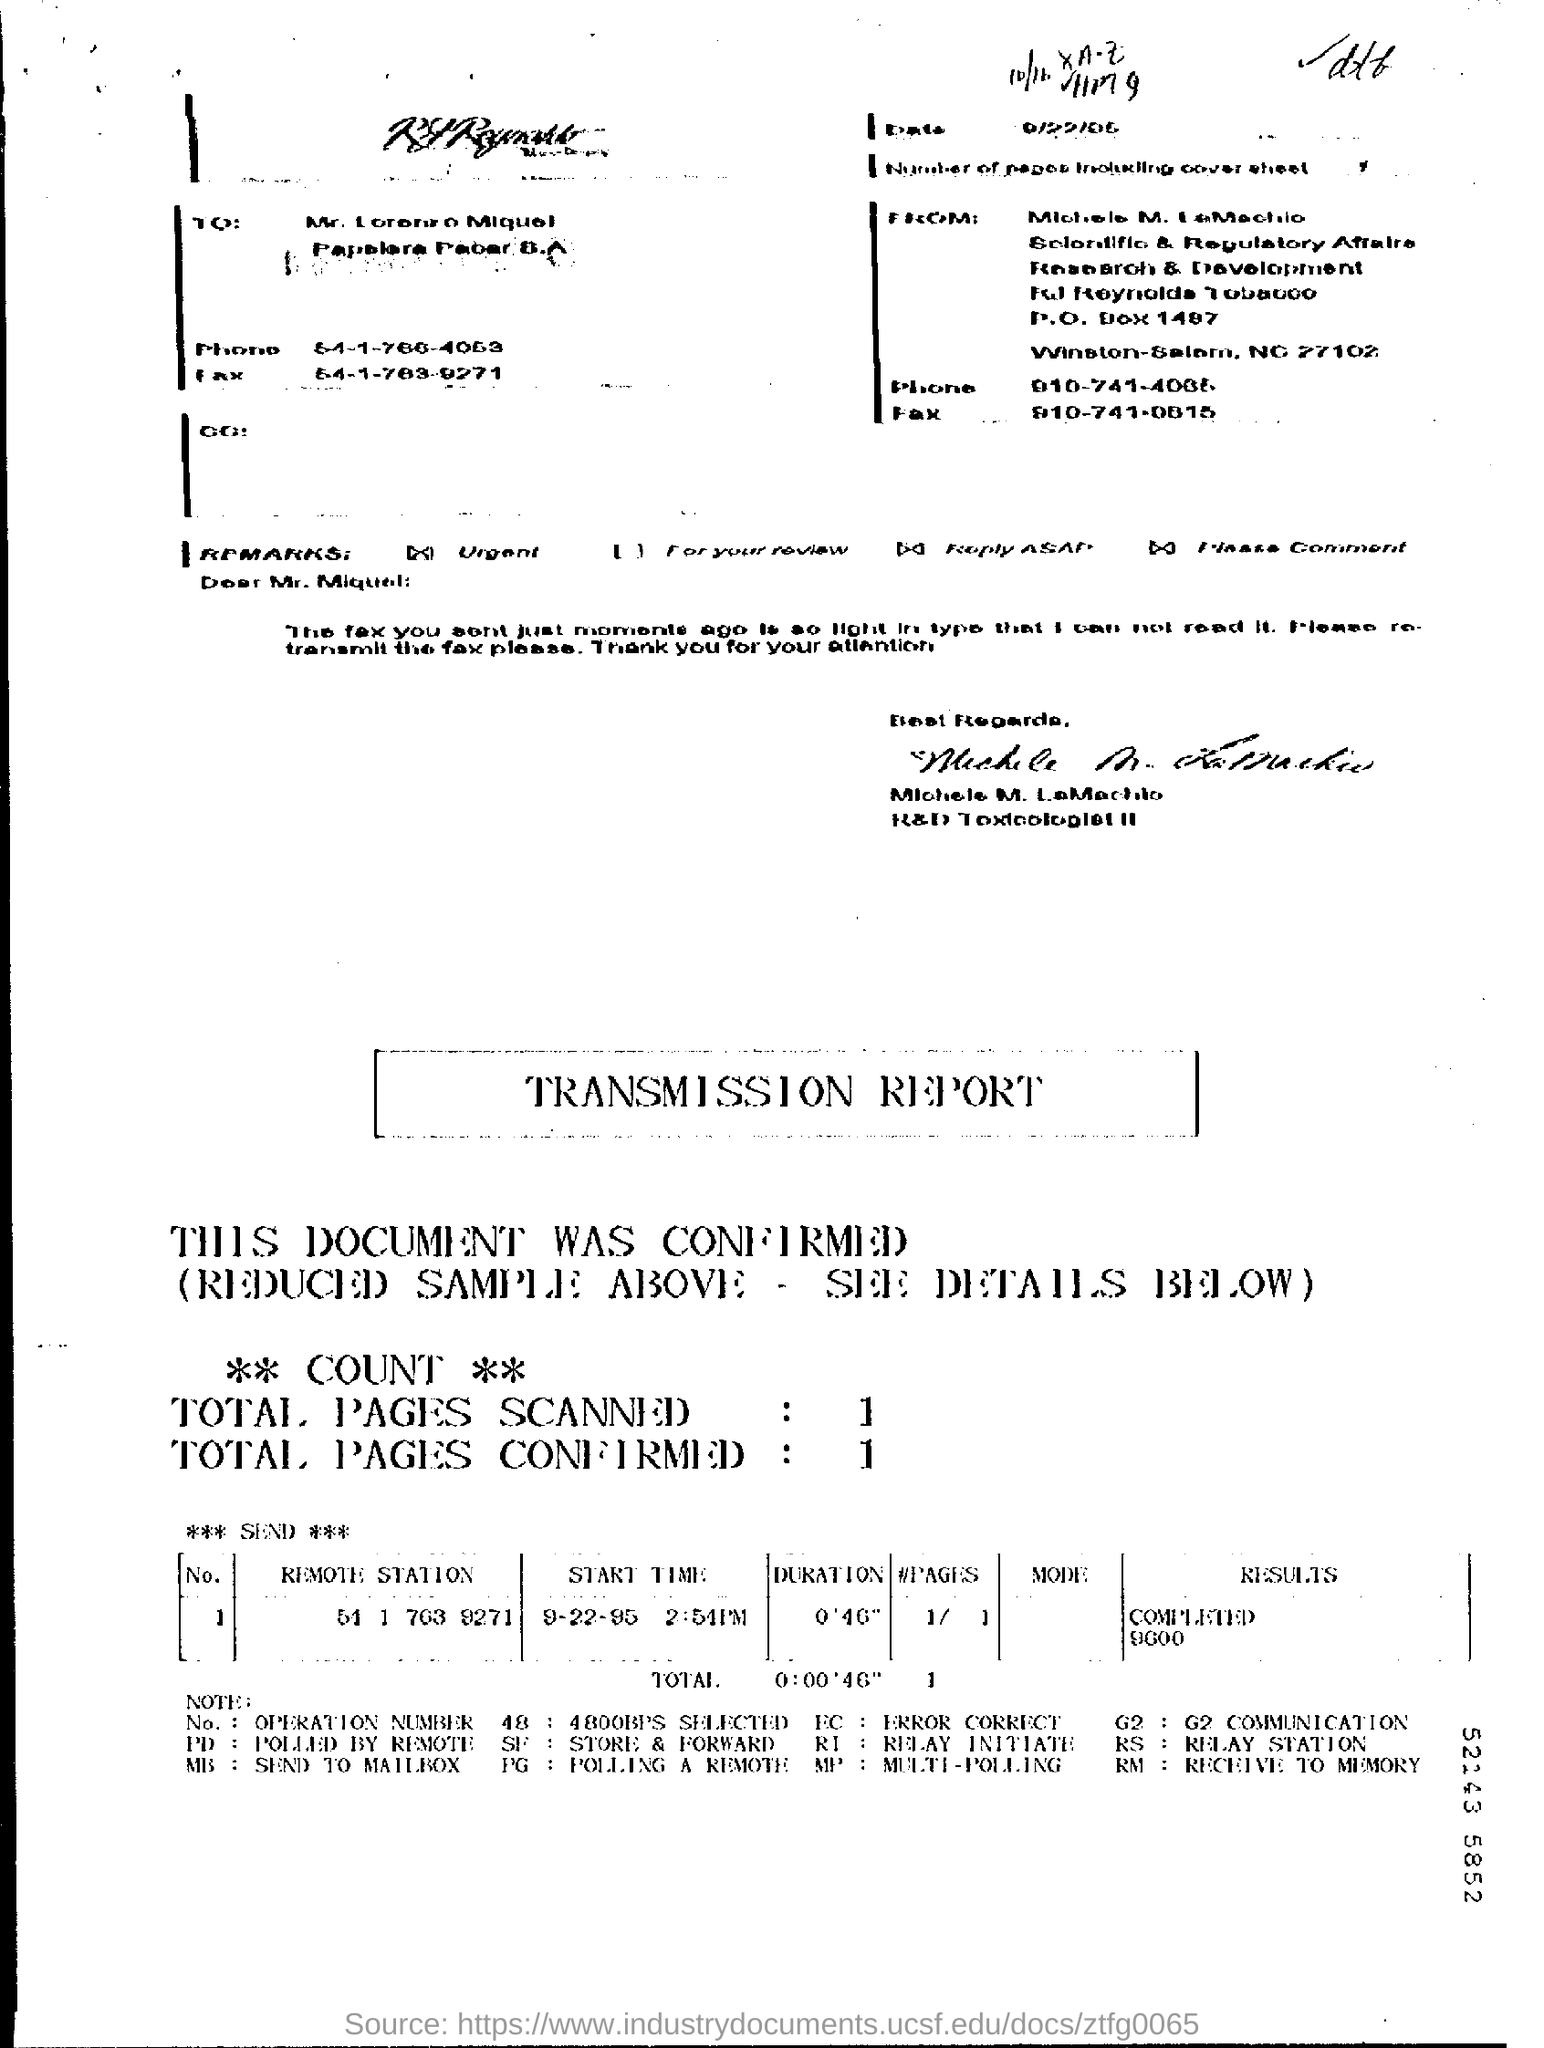Specify some key components in this picture. The start time for the remote station number 51 1 763 9271 is September 22, 1995 at 2:54 PM. The "Results" for the "Remote Station" with the phone number 51 1 763 9271 have been completed and are currently at 9600. 